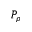Convert formula to latex. <formula><loc_0><loc_0><loc_500><loc_500>P _ { \rho }</formula> 